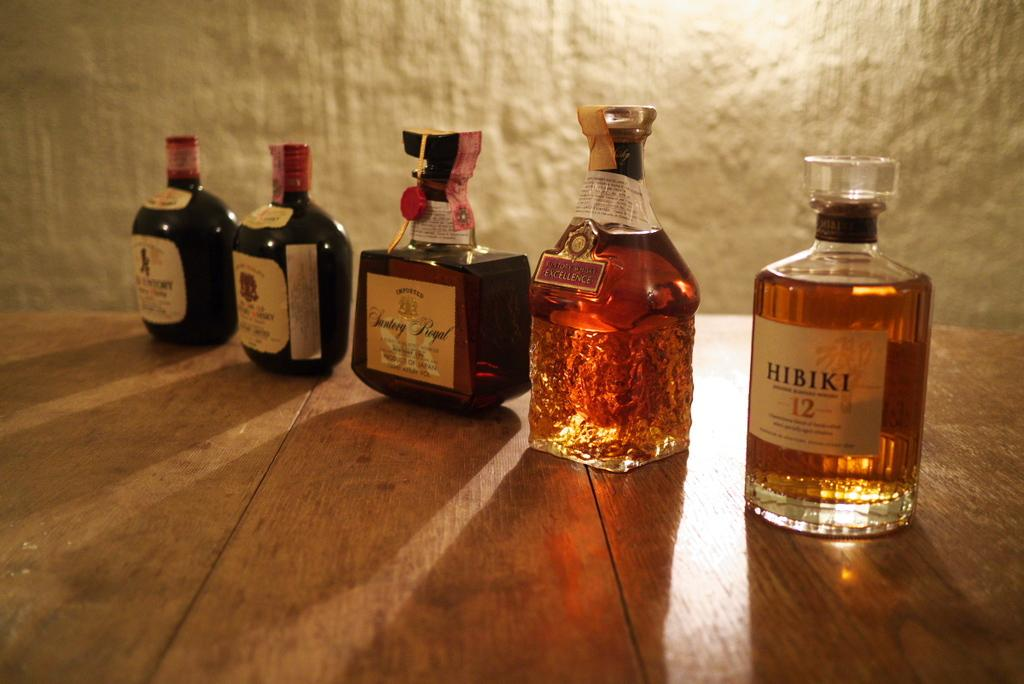<image>
Summarize the visual content of the image. a bottle of liquor that says Hibiki on it 